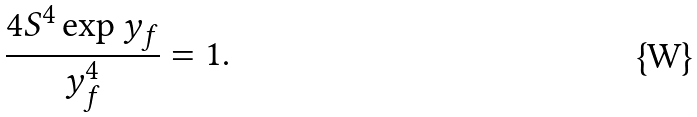Convert formula to latex. <formula><loc_0><loc_0><loc_500><loc_500>\frac { 4 S ^ { 4 } \exp { y _ { f } } } { y _ { f } ^ { 4 } } = 1 .</formula> 